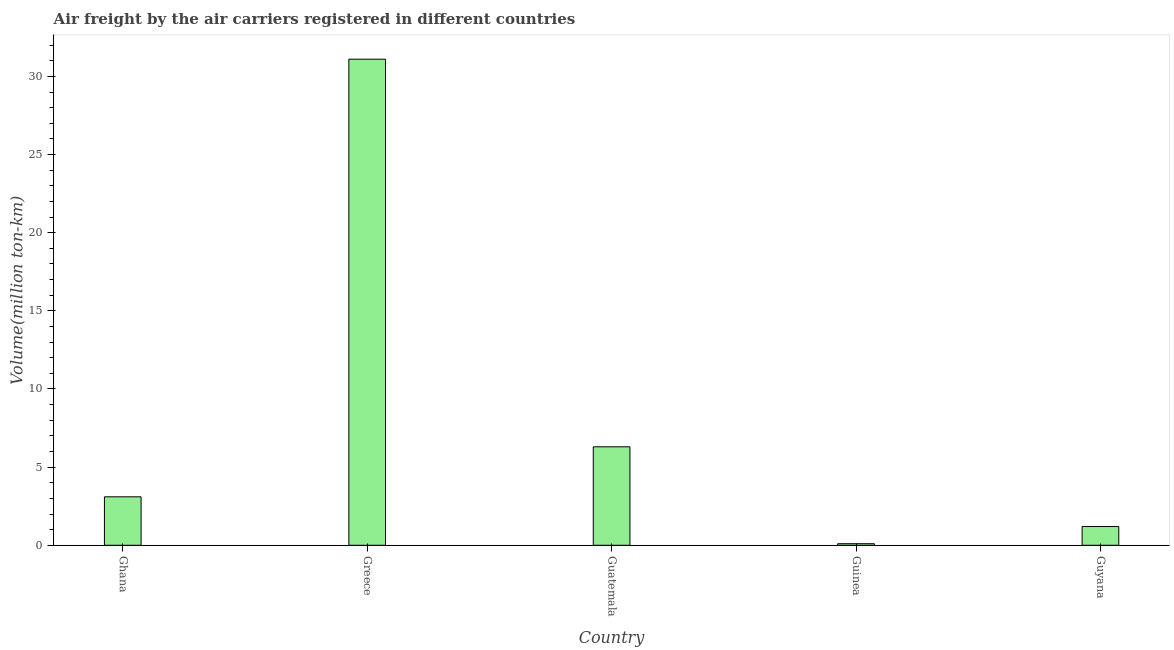Does the graph contain any zero values?
Give a very brief answer. No. What is the title of the graph?
Your response must be concise. Air freight by the air carriers registered in different countries. What is the label or title of the Y-axis?
Give a very brief answer. Volume(million ton-km). What is the air freight in Guinea?
Your answer should be compact. 0.1. Across all countries, what is the maximum air freight?
Provide a succinct answer. 31.1. Across all countries, what is the minimum air freight?
Your answer should be compact. 0.1. In which country was the air freight maximum?
Your response must be concise. Greece. In which country was the air freight minimum?
Your response must be concise. Guinea. What is the sum of the air freight?
Provide a short and direct response. 41.8. What is the average air freight per country?
Keep it short and to the point. 8.36. What is the median air freight?
Give a very brief answer. 3.1. Is the difference between the air freight in Guatemala and Guinea greater than the difference between any two countries?
Your answer should be very brief. No. What is the difference between the highest and the second highest air freight?
Your answer should be compact. 24.8. Is the sum of the air freight in Ghana and Guatemala greater than the maximum air freight across all countries?
Your answer should be very brief. No. In how many countries, is the air freight greater than the average air freight taken over all countries?
Your response must be concise. 1. How many bars are there?
Ensure brevity in your answer.  5. Are all the bars in the graph horizontal?
Your answer should be very brief. No. How many countries are there in the graph?
Ensure brevity in your answer.  5. What is the difference between two consecutive major ticks on the Y-axis?
Your response must be concise. 5. What is the Volume(million ton-km) in Ghana?
Ensure brevity in your answer.  3.1. What is the Volume(million ton-km) of Greece?
Your response must be concise. 31.1. What is the Volume(million ton-km) of Guatemala?
Make the answer very short. 6.3. What is the Volume(million ton-km) in Guinea?
Give a very brief answer. 0.1. What is the Volume(million ton-km) in Guyana?
Make the answer very short. 1.2. What is the difference between the Volume(million ton-km) in Ghana and Guatemala?
Make the answer very short. -3.2. What is the difference between the Volume(million ton-km) in Ghana and Guinea?
Your answer should be very brief. 3. What is the difference between the Volume(million ton-km) in Greece and Guatemala?
Provide a short and direct response. 24.8. What is the difference between the Volume(million ton-km) in Greece and Guyana?
Make the answer very short. 29.9. What is the difference between the Volume(million ton-km) in Guatemala and Guinea?
Keep it short and to the point. 6.2. What is the difference between the Volume(million ton-km) in Guatemala and Guyana?
Provide a succinct answer. 5.1. What is the ratio of the Volume(million ton-km) in Ghana to that in Guatemala?
Give a very brief answer. 0.49. What is the ratio of the Volume(million ton-km) in Ghana to that in Guinea?
Provide a short and direct response. 31. What is the ratio of the Volume(million ton-km) in Ghana to that in Guyana?
Ensure brevity in your answer.  2.58. What is the ratio of the Volume(million ton-km) in Greece to that in Guatemala?
Your answer should be compact. 4.94. What is the ratio of the Volume(million ton-km) in Greece to that in Guinea?
Make the answer very short. 311. What is the ratio of the Volume(million ton-km) in Greece to that in Guyana?
Offer a very short reply. 25.92. What is the ratio of the Volume(million ton-km) in Guatemala to that in Guinea?
Give a very brief answer. 63. What is the ratio of the Volume(million ton-km) in Guatemala to that in Guyana?
Your answer should be very brief. 5.25. What is the ratio of the Volume(million ton-km) in Guinea to that in Guyana?
Your answer should be compact. 0.08. 